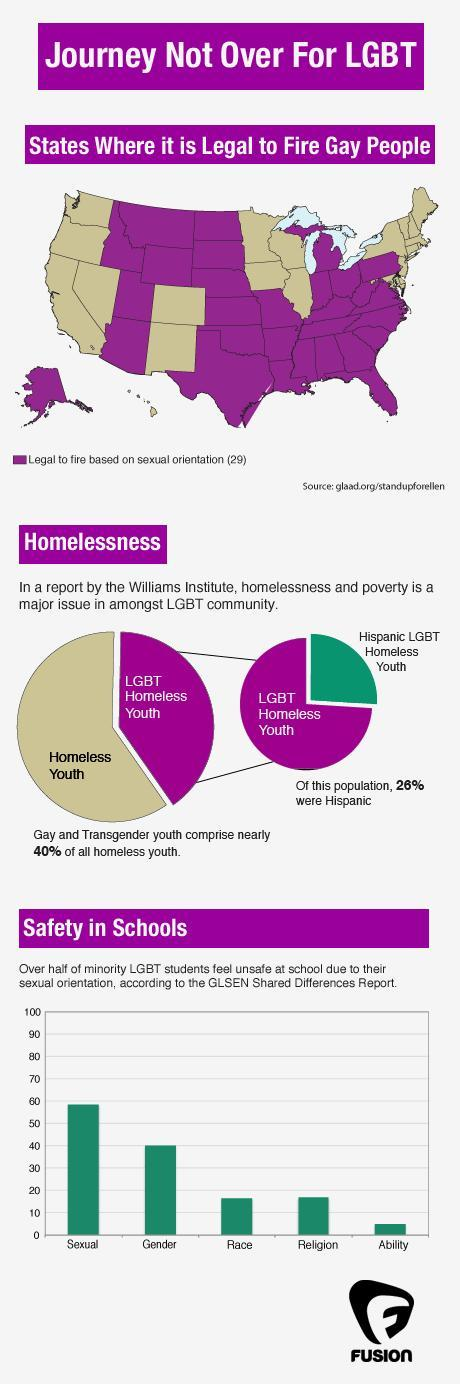What is the second highest reason for students to feel insecure?
Answer the question with a short phrase. gender What is percentage of LGBT homeless youth do not belong to the Hispanic community ? 74% In how many states it is not legal to fire gay people? 21 states 